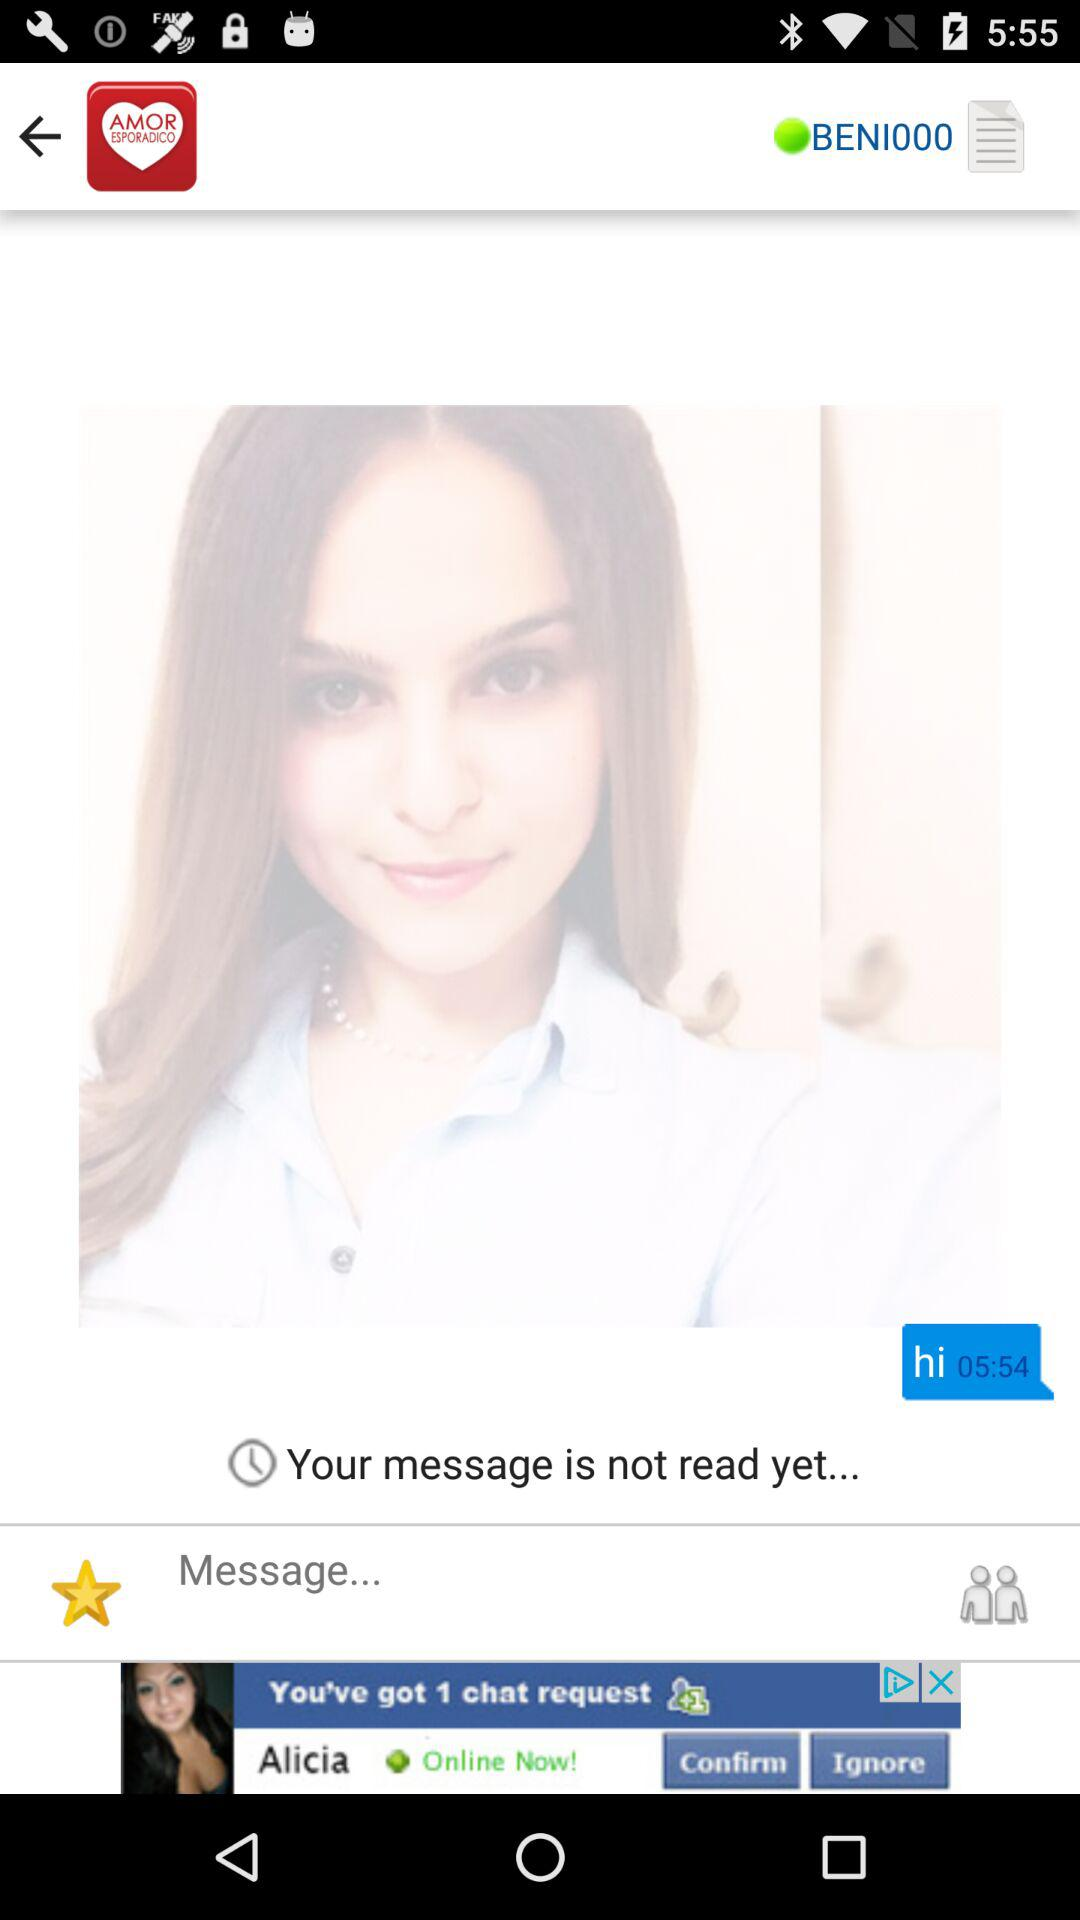What is the User profile name?
When the provided information is insufficient, respond with <no answer>. <no answer> 